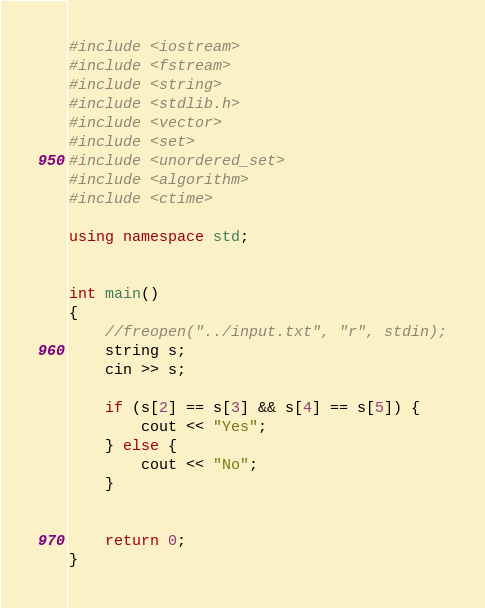Convert code to text. <code><loc_0><loc_0><loc_500><loc_500><_C++_>#include <iostream>
#include <fstream>
#include <string>
#include <stdlib.h>
#include <vector>
#include <set>
#include <unordered_set>
#include <algorithm>
#include <ctime>

using namespace std;


int main()
{
    //freopen("../input.txt", "r", stdin);
    string s;
    cin >> s;

    if (s[2] == s[3] && s[4] == s[5]) {
        cout << "Yes";
    } else {
        cout << "No";
    }


    return 0;
}

</code> 